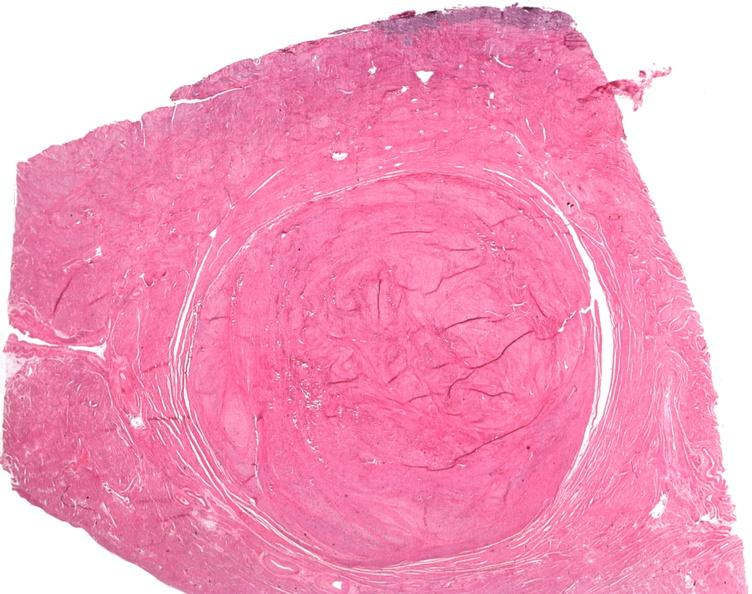s female reproductive present?
Answer the question using a single word or phrase. Yes 